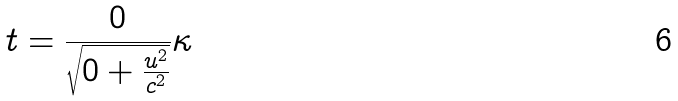Convert formula to latex. <formula><loc_0><loc_0><loc_500><loc_500>t = \frac { 0 } { \sqrt { 0 + \frac { u ^ { 2 } } { c ^ { 2 } } } } \kappa</formula> 